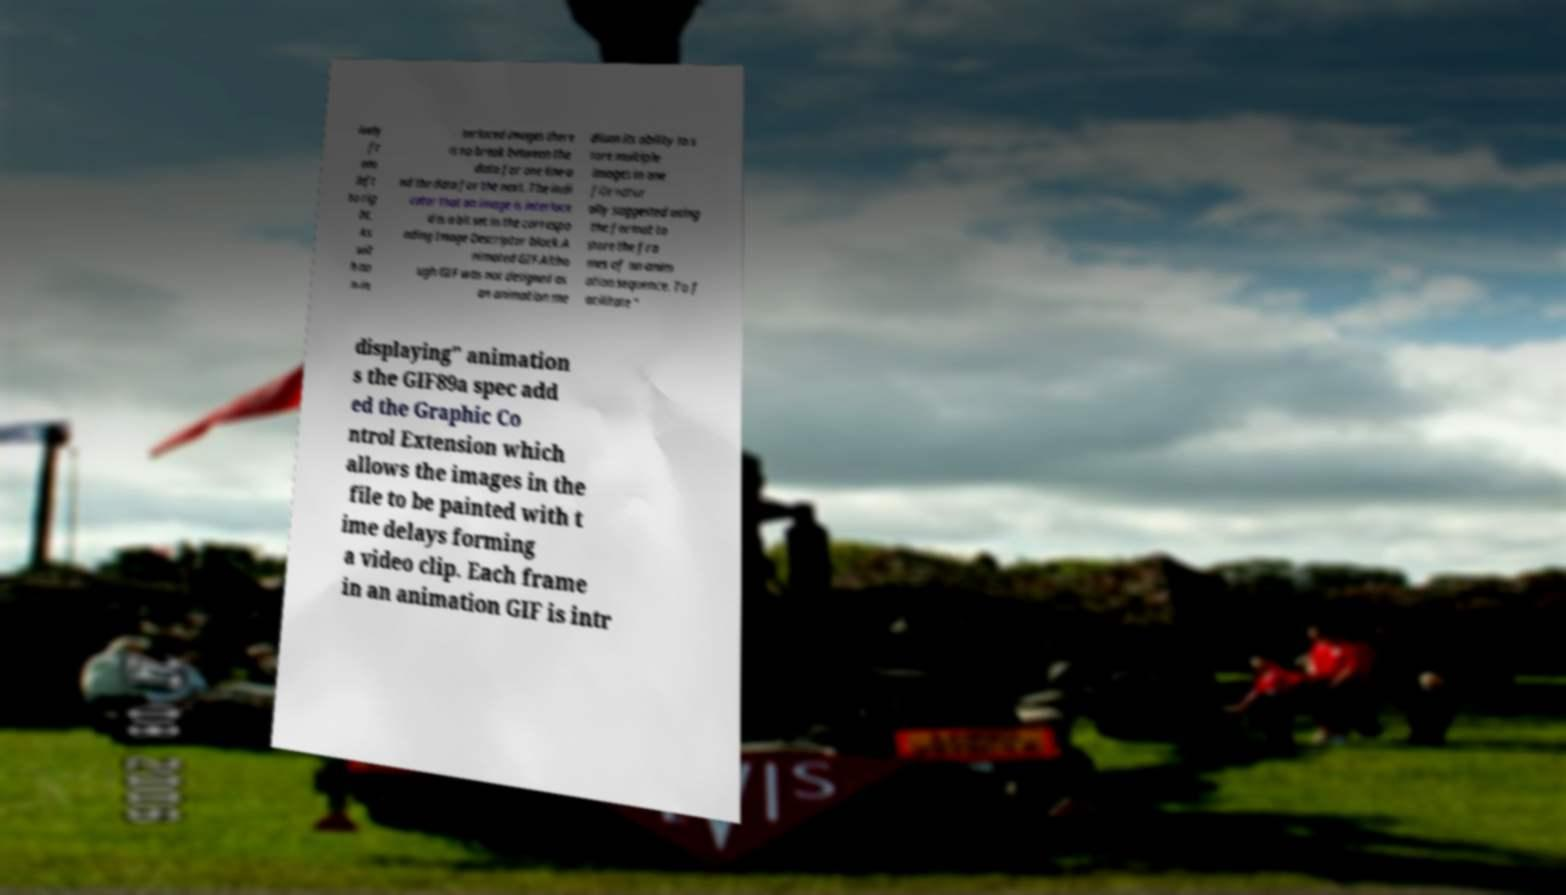I need the written content from this picture converted into text. Can you do that? ively fr om left to rig ht. As wit h no n-in terlaced images there is no break between the data for one line a nd the data for the next. The indi cator that an image is interlace d is a bit set in the correspo nding Image Descriptor block.A nimated GIF.Altho ugh GIF was not designed as an animation me dium its ability to s tore multiple images in one file natur ally suggested using the format to store the fra mes of an anim ation sequence. To f acilitate " displaying" animation s the GIF89a spec add ed the Graphic Co ntrol Extension which allows the images in the file to be painted with t ime delays forming a video clip. Each frame in an animation GIF is intr 